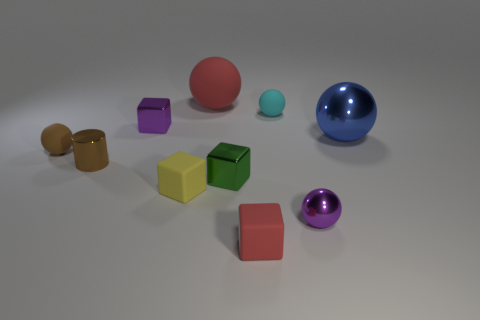There is a tiny rubber object that is the same color as the big rubber thing; what is its shape?
Offer a very short reply. Cube. Is there any other thing that has the same color as the tiny cylinder?
Make the answer very short. Yes. Do the rubber ball to the left of the brown metallic thing and the cylinder have the same color?
Provide a short and direct response. Yes. Is there a tiny shiny block of the same color as the small metal ball?
Your answer should be very brief. Yes. Are there the same number of metallic cubes that are on the right side of the tiny red matte thing and big yellow rubber cubes?
Offer a terse response. Yes. How many red spheres are there?
Keep it short and to the point. 1. The small rubber object that is both to the left of the large red rubber ball and right of the cylinder has what shape?
Offer a very short reply. Cube. There is a matte block in front of the yellow object; is its color the same as the big ball that is behind the blue ball?
Keep it short and to the point. Yes. The matte ball that is the same color as the metallic cylinder is what size?
Offer a very short reply. Small. Is there another tiny cyan ball made of the same material as the cyan ball?
Keep it short and to the point. No. 